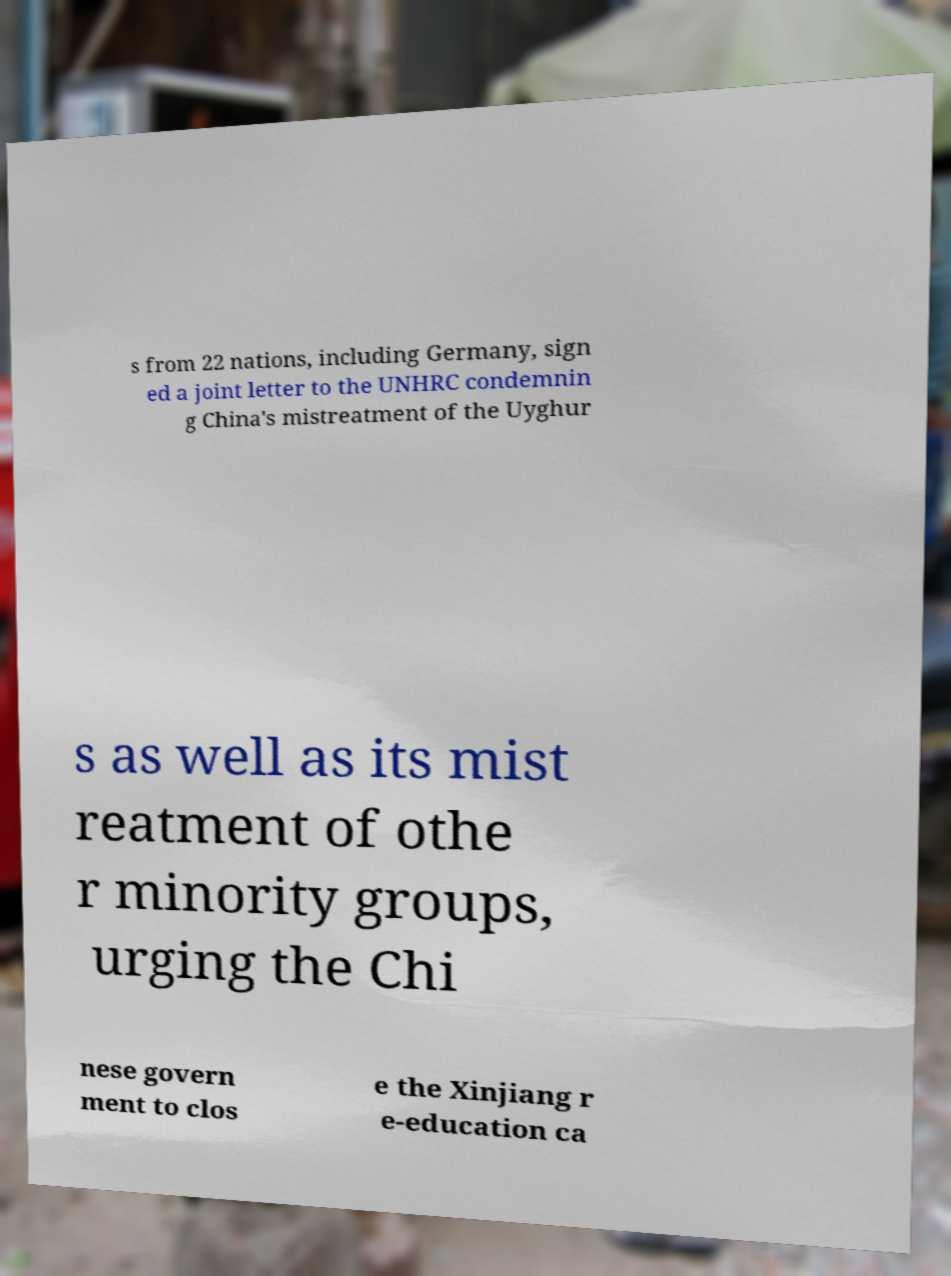Could you assist in decoding the text presented in this image and type it out clearly? s from 22 nations, including Germany, sign ed a joint letter to the UNHRC condemnin g China's mistreatment of the Uyghur s as well as its mist reatment of othe r minority groups, urging the Chi nese govern ment to clos e the Xinjiang r e-education ca 